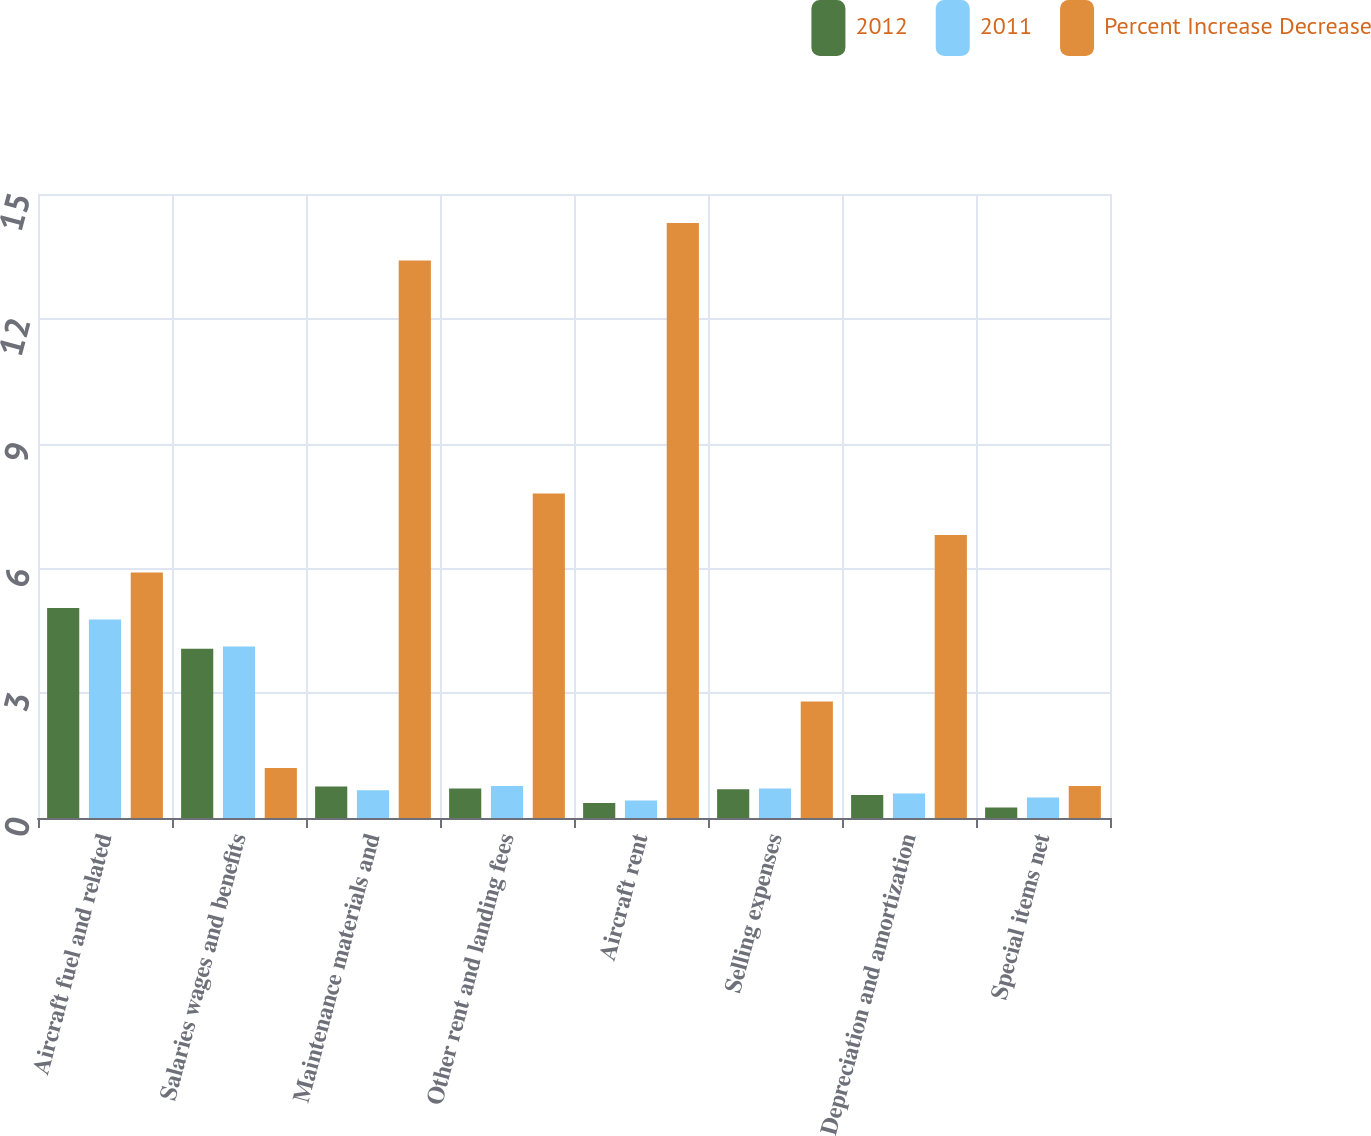Convert chart to OTSL. <chart><loc_0><loc_0><loc_500><loc_500><stacked_bar_chart><ecel><fcel>Aircraft fuel and related<fcel>Salaries wages and benefits<fcel>Maintenance materials and<fcel>Other rent and landing fees<fcel>Aircraft rent<fcel>Selling expenses<fcel>Depreciation and amortization<fcel>Special items net<nl><fcel>2012<fcel>5.05<fcel>4.07<fcel>0.76<fcel>0.71<fcel>0.36<fcel>0.69<fcel>0.55<fcel>0.25<nl><fcel>2011<fcel>4.77<fcel>4.12<fcel>0.67<fcel>0.77<fcel>0.42<fcel>0.71<fcel>0.59<fcel>0.49<nl><fcel>Percent Increase Decrease<fcel>5.9<fcel>1.2<fcel>13.4<fcel>7.8<fcel>14.3<fcel>2.8<fcel>6.8<fcel>0.77<nl></chart> 